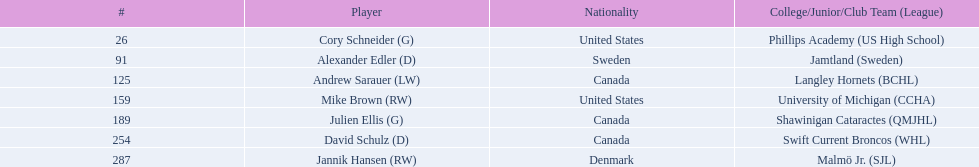What number of players have canada listed as their nationality? 3. 